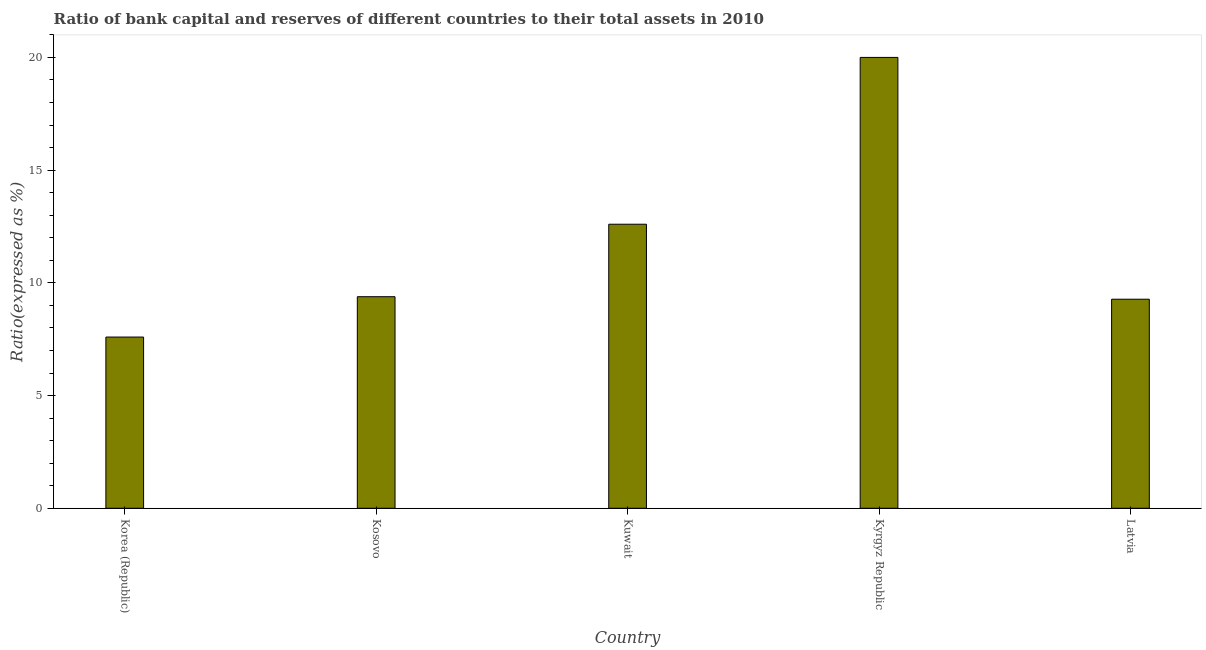Does the graph contain grids?
Offer a terse response. No. What is the title of the graph?
Give a very brief answer. Ratio of bank capital and reserves of different countries to their total assets in 2010. What is the label or title of the Y-axis?
Ensure brevity in your answer.  Ratio(expressed as %). What is the bank capital to assets ratio in Kosovo?
Provide a succinct answer. 9.39. Across all countries, what is the maximum bank capital to assets ratio?
Provide a short and direct response. 20. Across all countries, what is the minimum bank capital to assets ratio?
Your response must be concise. 7.6. In which country was the bank capital to assets ratio maximum?
Your answer should be compact. Kyrgyz Republic. What is the sum of the bank capital to assets ratio?
Ensure brevity in your answer.  58.85. What is the difference between the bank capital to assets ratio in Kosovo and Kyrgyz Republic?
Give a very brief answer. -10.62. What is the average bank capital to assets ratio per country?
Offer a terse response. 11.77. What is the median bank capital to assets ratio?
Your answer should be compact. 9.39. In how many countries, is the bank capital to assets ratio greater than 7 %?
Make the answer very short. 5. What is the ratio of the bank capital to assets ratio in Korea (Republic) to that in Latvia?
Offer a very short reply. 0.82. What is the difference between the highest and the lowest bank capital to assets ratio?
Your answer should be compact. 12.4. In how many countries, is the bank capital to assets ratio greater than the average bank capital to assets ratio taken over all countries?
Give a very brief answer. 2. Are all the bars in the graph horizontal?
Offer a terse response. No. What is the difference between two consecutive major ticks on the Y-axis?
Give a very brief answer. 5. What is the Ratio(expressed as %) in Korea (Republic)?
Provide a short and direct response. 7.6. What is the Ratio(expressed as %) in Kosovo?
Keep it short and to the point. 9.39. What is the Ratio(expressed as %) in Kuwait?
Your answer should be compact. 12.6. What is the Ratio(expressed as %) in Kyrgyz Republic?
Your answer should be compact. 20. What is the Ratio(expressed as %) in Latvia?
Keep it short and to the point. 9.27. What is the difference between the Ratio(expressed as %) in Korea (Republic) and Kosovo?
Keep it short and to the point. -1.79. What is the difference between the Ratio(expressed as %) in Korea (Republic) and Kuwait?
Give a very brief answer. -5. What is the difference between the Ratio(expressed as %) in Korea (Republic) and Kyrgyz Republic?
Give a very brief answer. -12.4. What is the difference between the Ratio(expressed as %) in Korea (Republic) and Latvia?
Provide a short and direct response. -1.68. What is the difference between the Ratio(expressed as %) in Kosovo and Kuwait?
Your response must be concise. -3.21. What is the difference between the Ratio(expressed as %) in Kosovo and Kyrgyz Republic?
Provide a succinct answer. -10.61. What is the difference between the Ratio(expressed as %) in Kosovo and Latvia?
Your response must be concise. 0.11. What is the difference between the Ratio(expressed as %) in Kuwait and Kyrgyz Republic?
Offer a very short reply. -7.4. What is the difference between the Ratio(expressed as %) in Kuwait and Latvia?
Provide a short and direct response. 3.33. What is the difference between the Ratio(expressed as %) in Kyrgyz Republic and Latvia?
Make the answer very short. 10.73. What is the ratio of the Ratio(expressed as %) in Korea (Republic) to that in Kosovo?
Keep it short and to the point. 0.81. What is the ratio of the Ratio(expressed as %) in Korea (Republic) to that in Kuwait?
Your answer should be compact. 0.6. What is the ratio of the Ratio(expressed as %) in Korea (Republic) to that in Kyrgyz Republic?
Your response must be concise. 0.38. What is the ratio of the Ratio(expressed as %) in Korea (Republic) to that in Latvia?
Offer a terse response. 0.82. What is the ratio of the Ratio(expressed as %) in Kosovo to that in Kuwait?
Provide a short and direct response. 0.74. What is the ratio of the Ratio(expressed as %) in Kosovo to that in Kyrgyz Republic?
Provide a short and direct response. 0.47. What is the ratio of the Ratio(expressed as %) in Kuwait to that in Kyrgyz Republic?
Keep it short and to the point. 0.63. What is the ratio of the Ratio(expressed as %) in Kuwait to that in Latvia?
Your response must be concise. 1.36. What is the ratio of the Ratio(expressed as %) in Kyrgyz Republic to that in Latvia?
Your answer should be very brief. 2.16. 